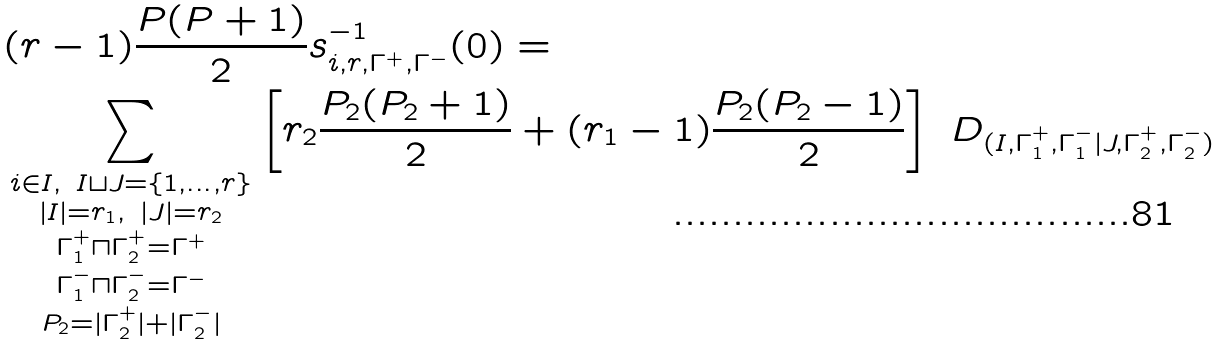Convert formula to latex. <formula><loc_0><loc_0><loc_500><loc_500>& ( r - 1 ) \frac { P ( P + 1 ) } { 2 } s _ { i , r , \Gamma ^ { + } , \Gamma ^ { - } } ^ { - 1 } ( 0 ) = \\ & \sum _ { \substack { i \in I , \ I \sqcup J = \{ 1 , \dots , r \} \\ | I | = r _ { 1 } , \ | J | = r _ { 2 } \\ \Gamma ^ { + } _ { 1 } \sqcap \Gamma ^ { + } _ { 2 } = \Gamma ^ { + } \\ \Gamma ^ { - } _ { 1 } \sqcap \Gamma ^ { - } _ { 2 } = \Gamma ^ { - } \\ P _ { 2 } = | \Gamma ^ { + } _ { 2 } | + | \Gamma ^ { - } _ { 2 } | } } \left [ r _ { 2 } \frac { P _ { 2 } ( P _ { 2 } + 1 ) } { 2 } + ( r _ { 1 } - 1 ) \frac { P _ { 2 } ( P _ { 2 } - 1 ) } { 2 } \right ] \ D _ { ( I , \Gamma ^ { + } _ { 1 } , \Gamma ^ { - } _ { 1 } | J , \Gamma ^ { + } _ { 2 } , \Gamma ^ { - } _ { 2 } ) }</formula> 